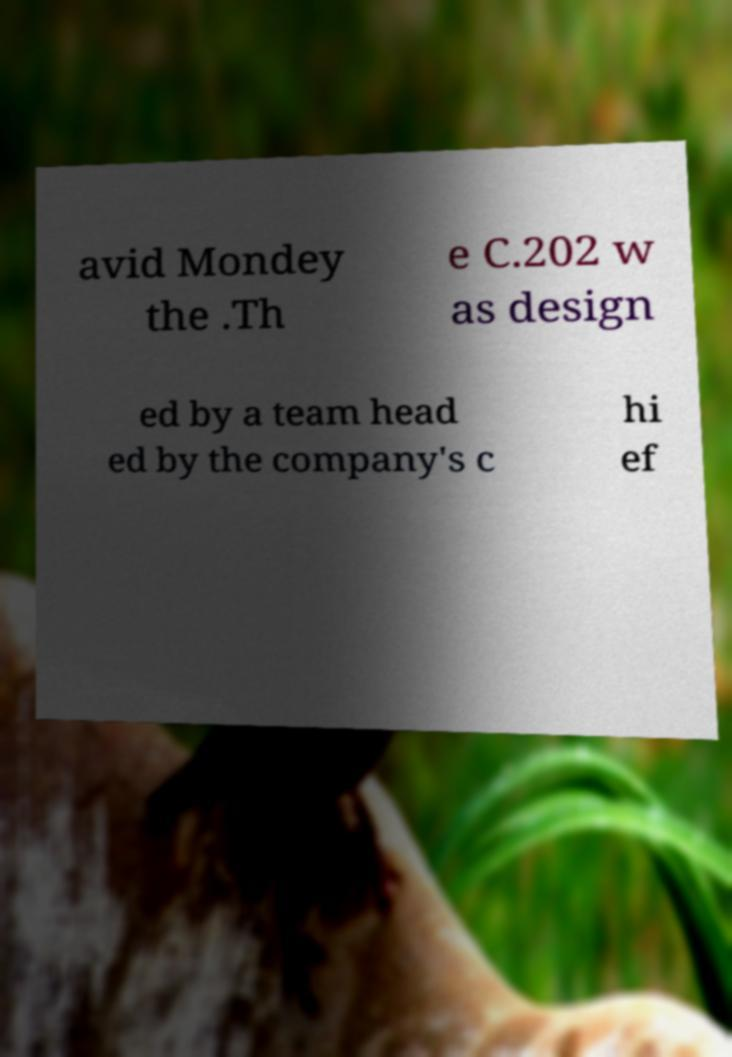Please identify and transcribe the text found in this image. avid Mondey the .Th e C.202 w as design ed by a team head ed by the company's c hi ef 